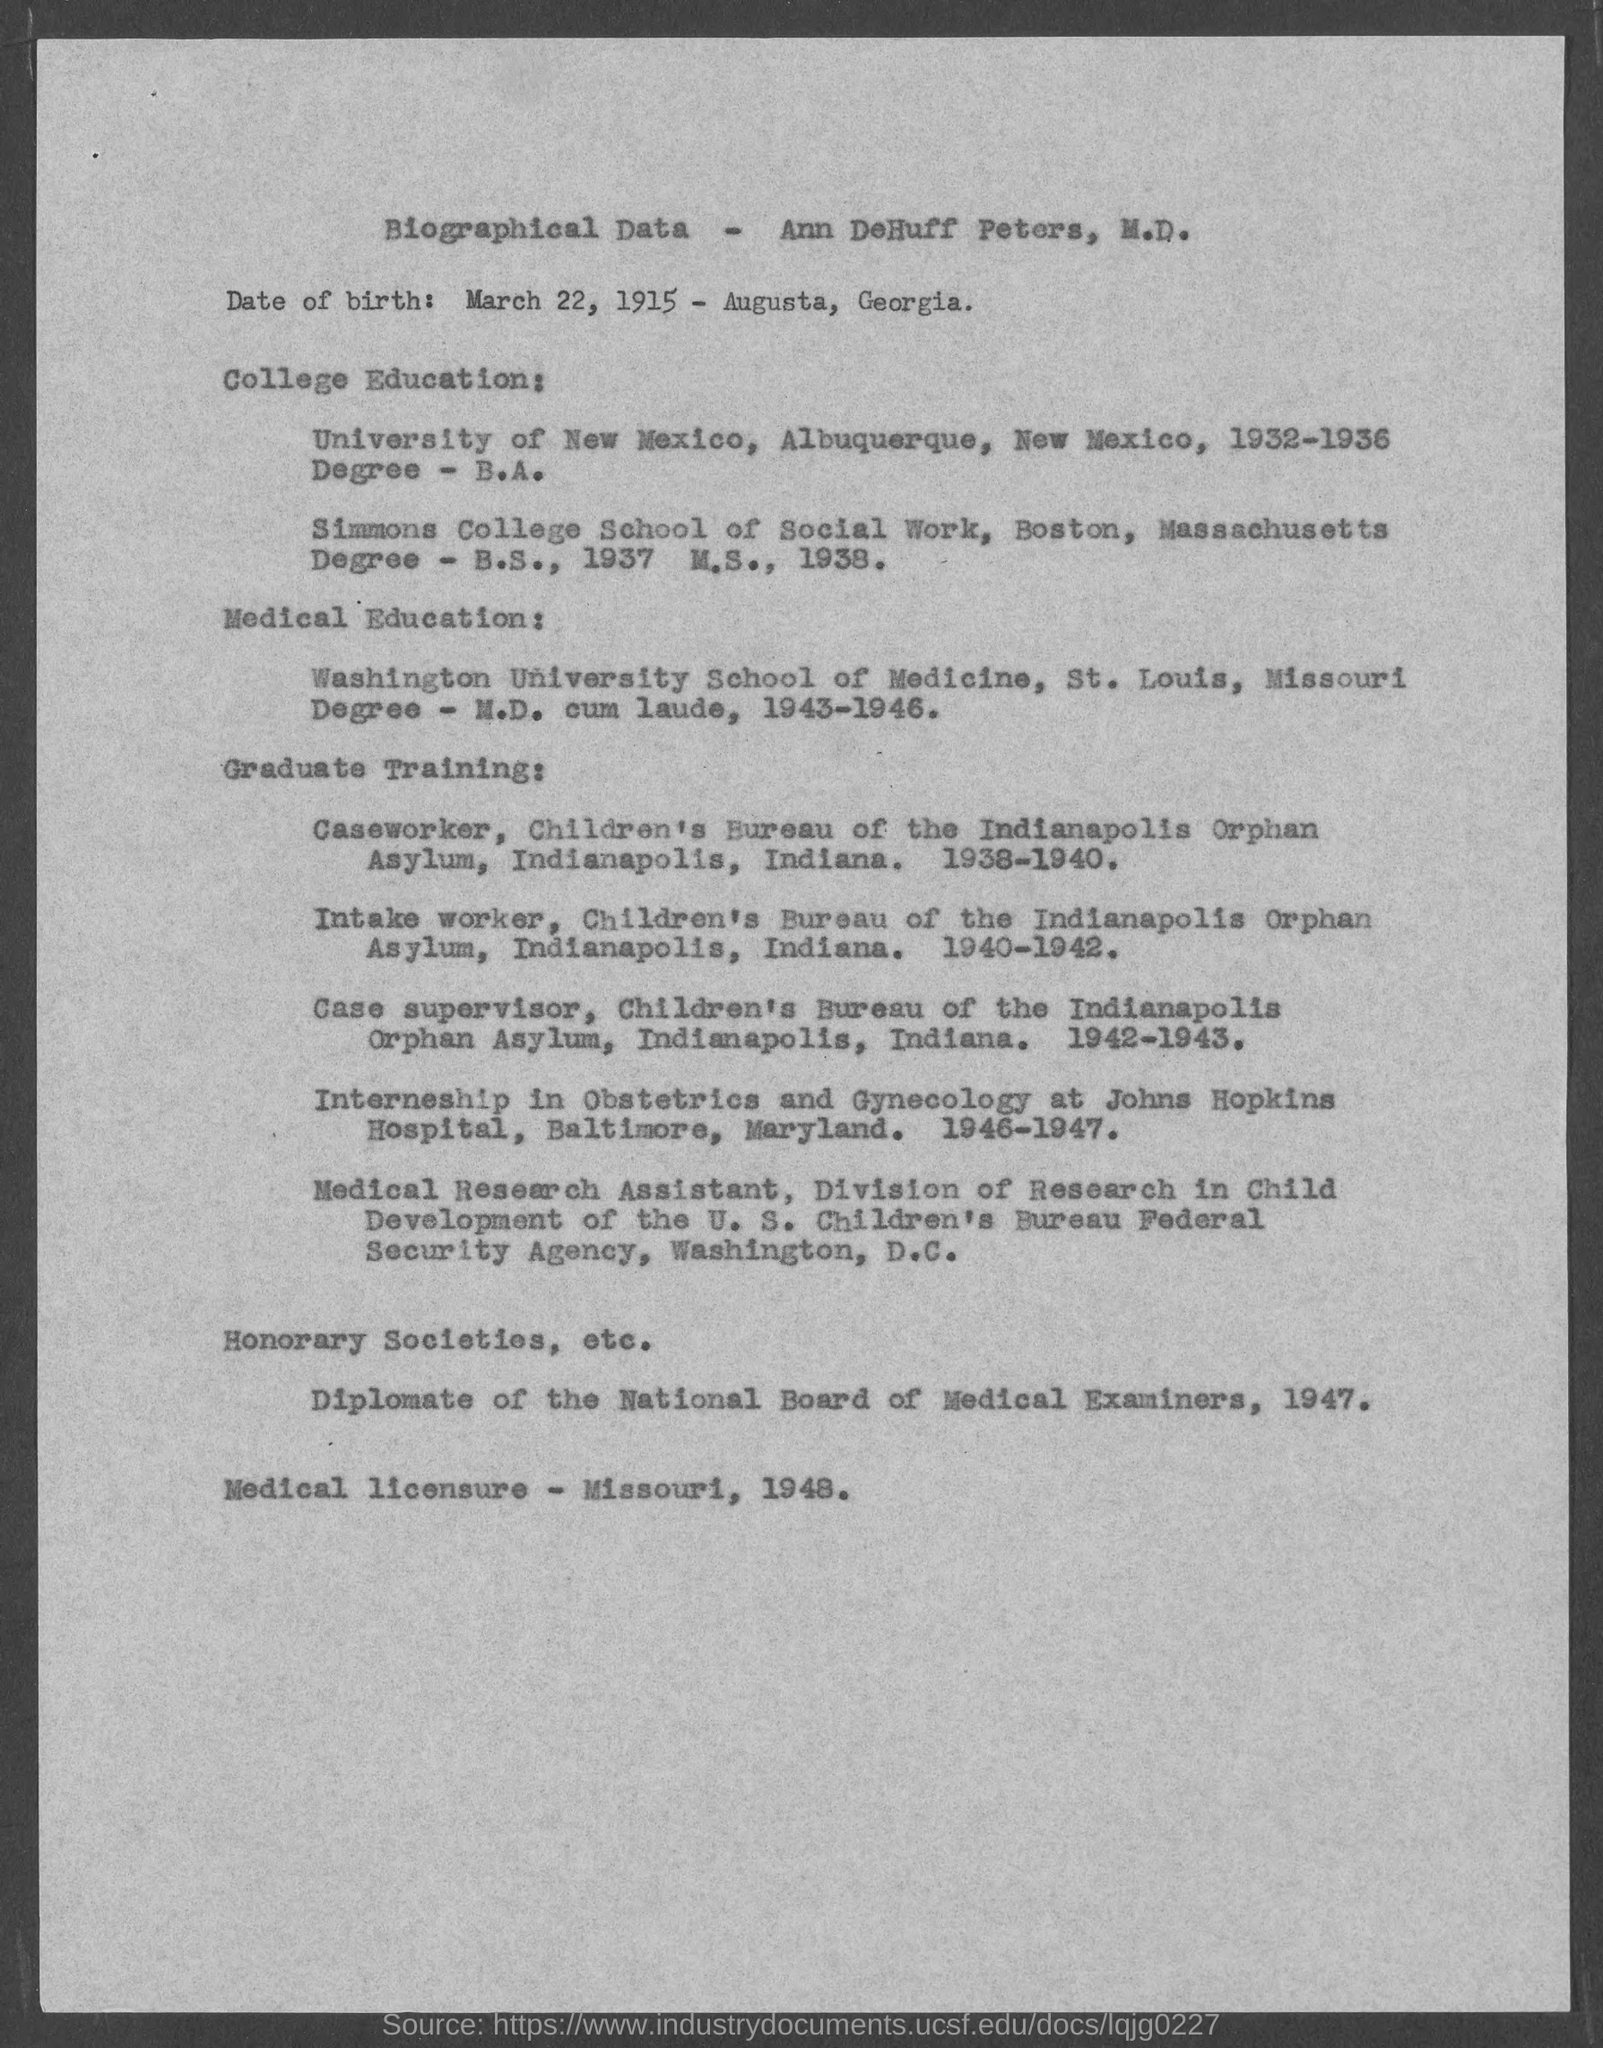Outline some significant characteristics in this image. Ann DeHuff Peters, M.D. completed her B.A. degree at the University of New Mexico. Ann DeHuff Peters is the individual whose biographical data is being provided. Ann DeHuff Peters, M.D. obtained her medical licensure in 1948. 